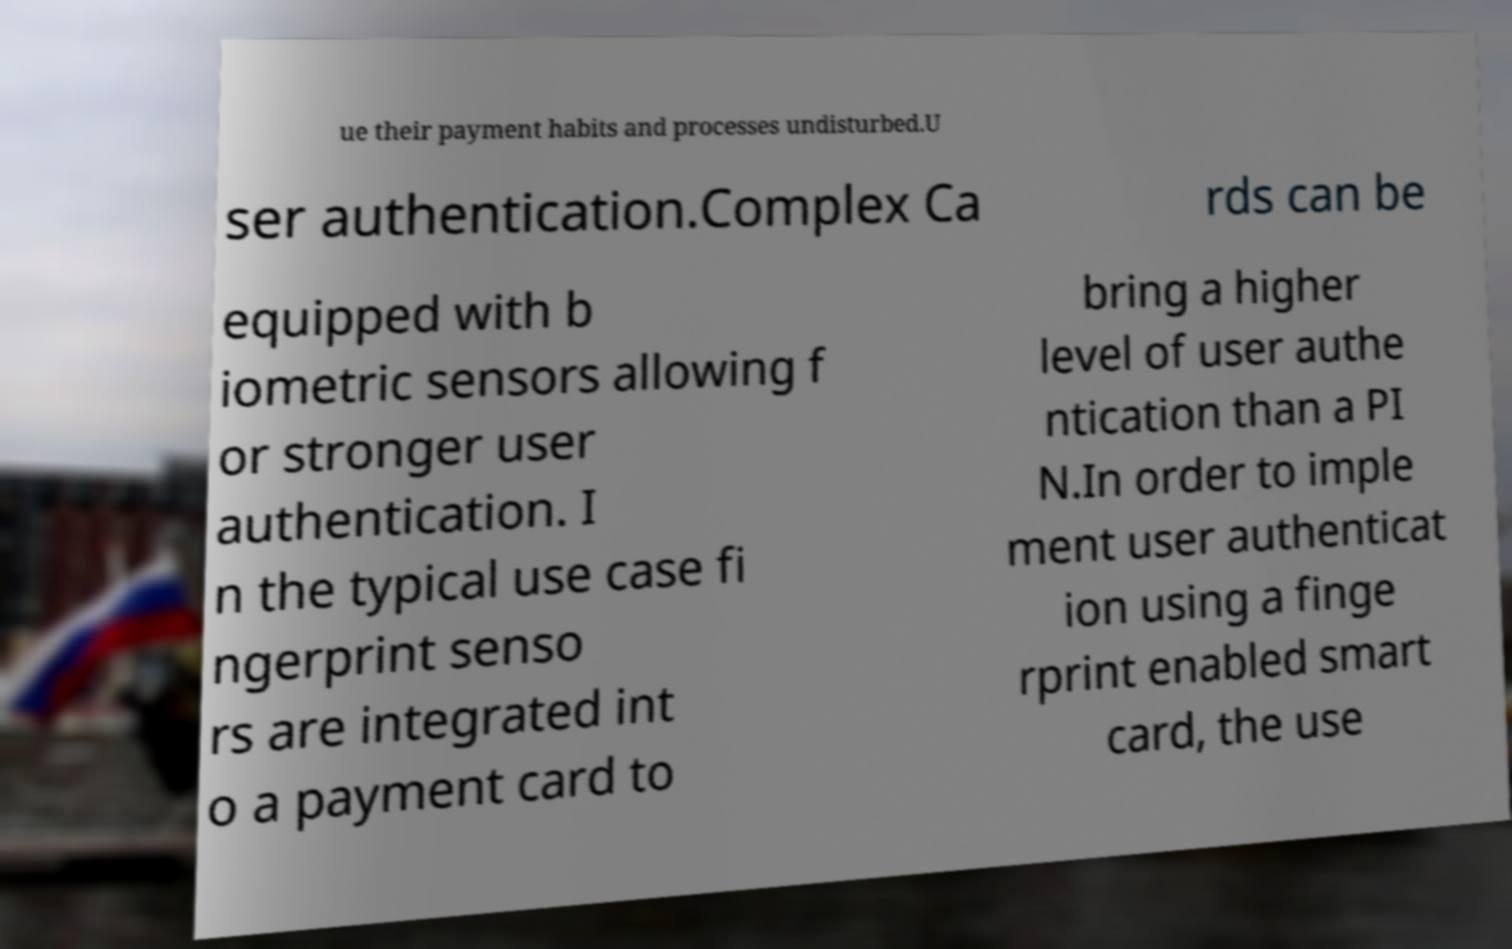Can you accurately transcribe the text from the provided image for me? ue their payment habits and processes undisturbed.U ser authentication.Complex Ca rds can be equipped with b iometric sensors allowing f or stronger user authentication. I n the typical use case fi ngerprint senso rs are integrated int o a payment card to bring a higher level of user authe ntication than a PI N.In order to imple ment user authenticat ion using a finge rprint enabled smart card, the use 